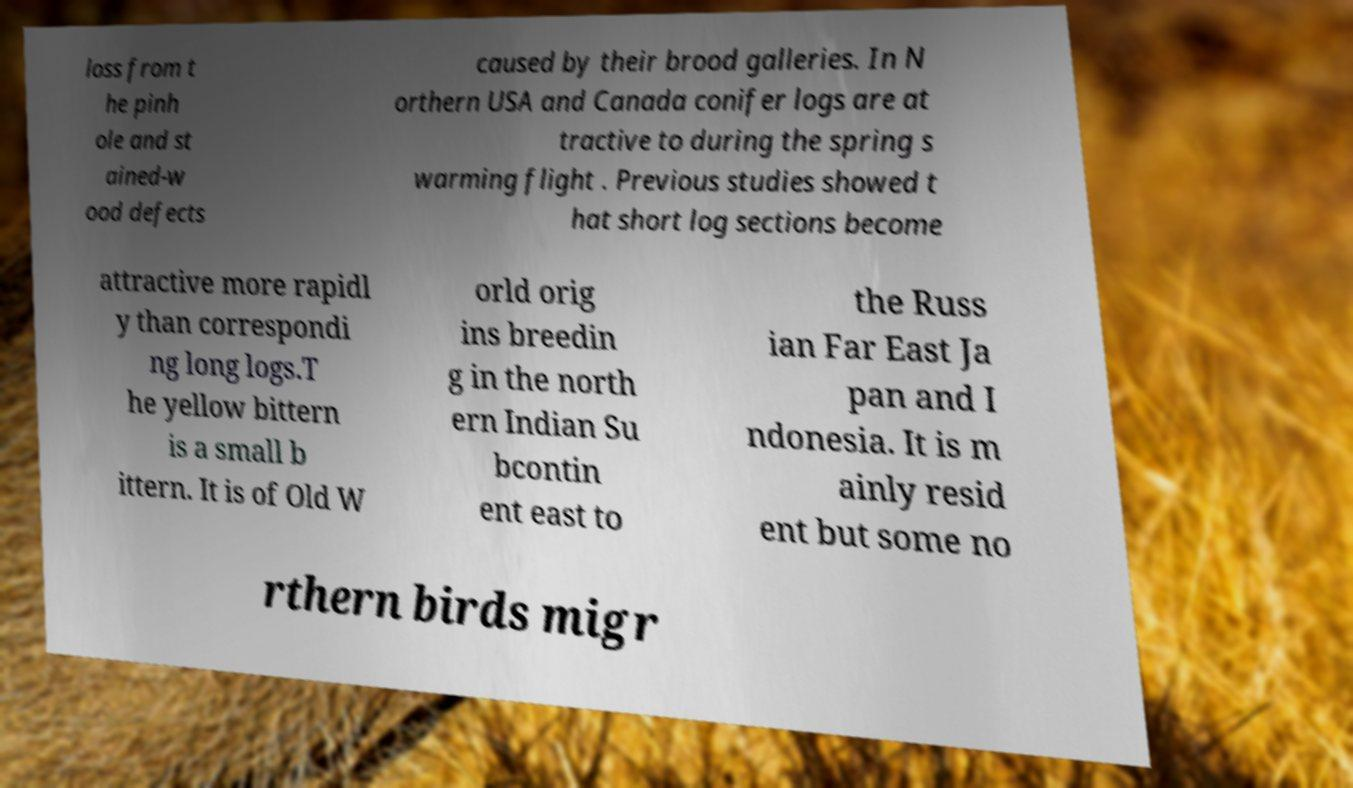Could you extract and type out the text from this image? loss from t he pinh ole and st ained-w ood defects caused by their brood galleries. In N orthern USA and Canada conifer logs are at tractive to during the spring s warming flight . Previous studies showed t hat short log sections become attractive more rapidl y than correspondi ng long logs.T he yellow bittern is a small b ittern. It is of Old W orld orig ins breedin g in the north ern Indian Su bcontin ent east to the Russ ian Far East Ja pan and I ndonesia. It is m ainly resid ent but some no rthern birds migr 